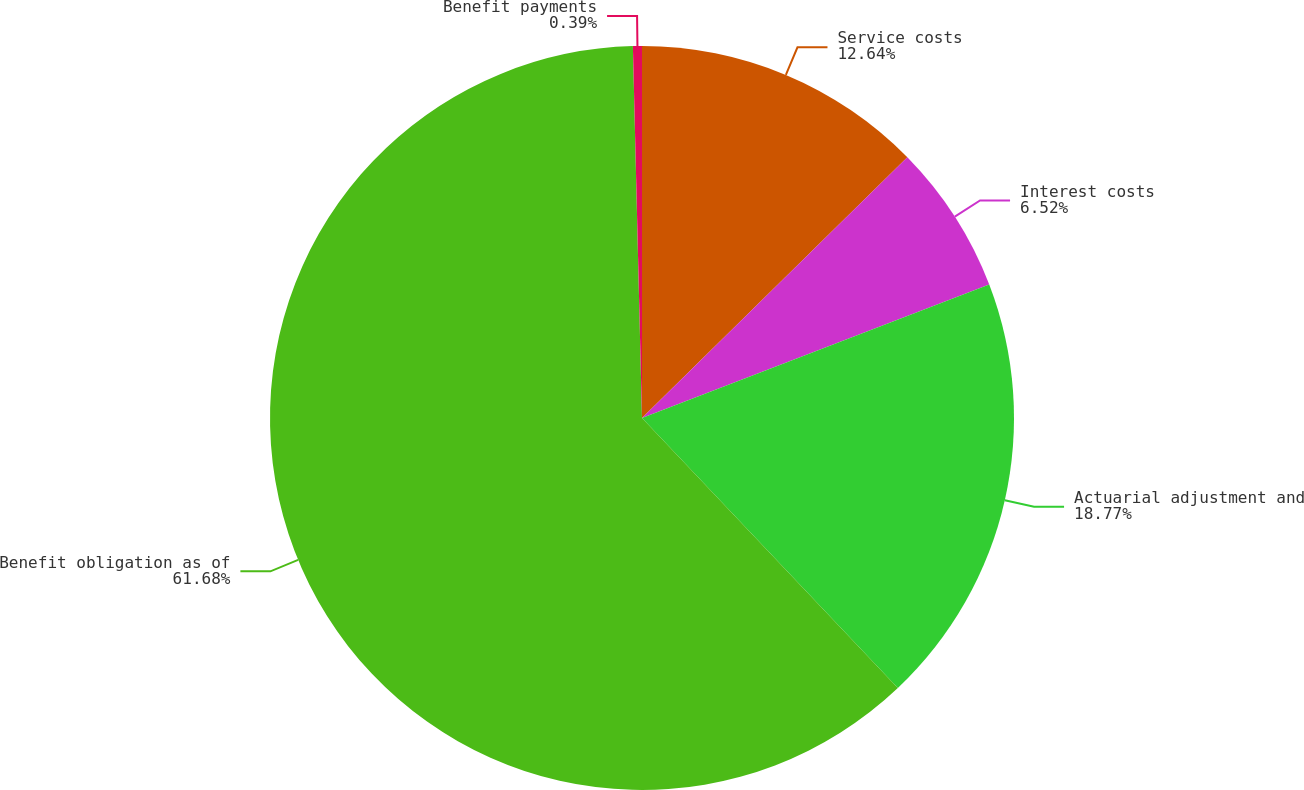<chart> <loc_0><loc_0><loc_500><loc_500><pie_chart><fcel>Service costs<fcel>Interest costs<fcel>Actuarial adjustment and<fcel>Benefit obligation as of<fcel>Benefit payments<nl><fcel>12.64%<fcel>6.52%<fcel>18.77%<fcel>61.68%<fcel>0.39%<nl></chart> 